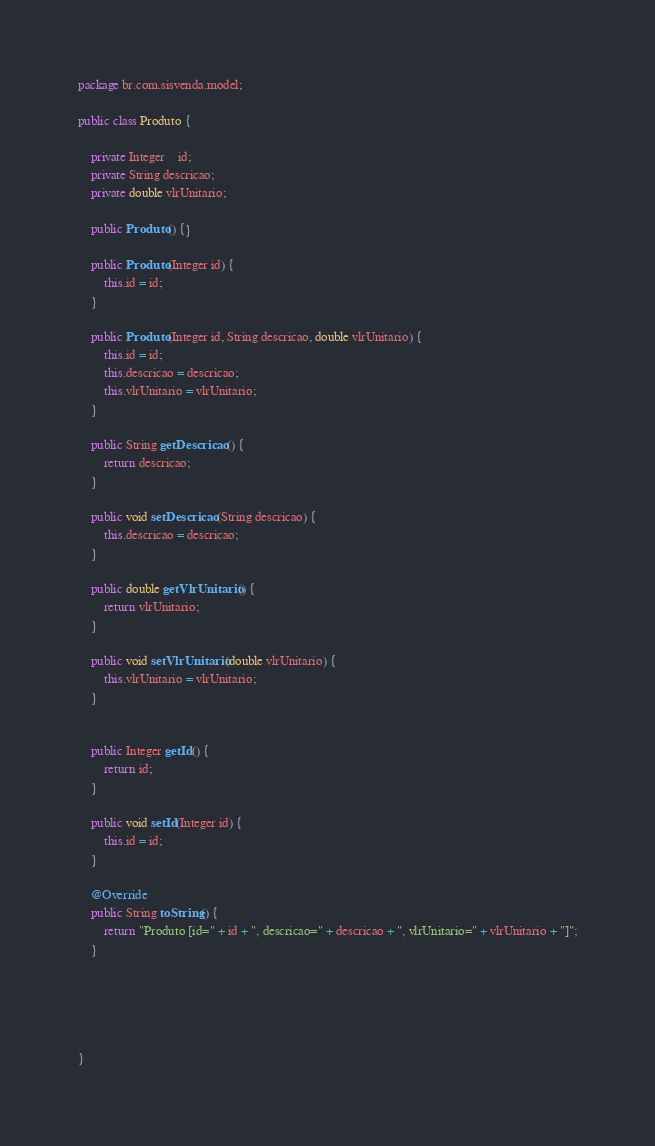<code> <loc_0><loc_0><loc_500><loc_500><_Java_>package br.com.sisvenda.model;

public class Produto {
	
	private Integer	id;
	private String descricao;
	private double vlrUnitario;
	
	public Produto() {}
	
	public Produto(Integer id) {
		this.id = id;
	}

	public Produto(Integer id, String descricao, double vlrUnitario) {
		this.id = id;
		this.descricao = descricao;
		this.vlrUnitario = vlrUnitario;
	}

	public String getDescricao() {
		return descricao;
	}

	public void setDescricao(String descricao) {
		this.descricao = descricao;
	}

	public double getVlrUnitario() {
		return vlrUnitario;
	}

	public void setVlrUnitario(double vlrUnitario) {
		this.vlrUnitario = vlrUnitario;
	}
	

	public Integer getId() {
		return id;
	}

	public void setId(Integer id) {
		this.id = id;
	}

	@Override
	public String toString() {
		return "Produto [id=" + id + ", descricao=" + descricao + ", vlrUnitario=" + vlrUnitario + "]";
	}
	
	
	
	

}
</code> 